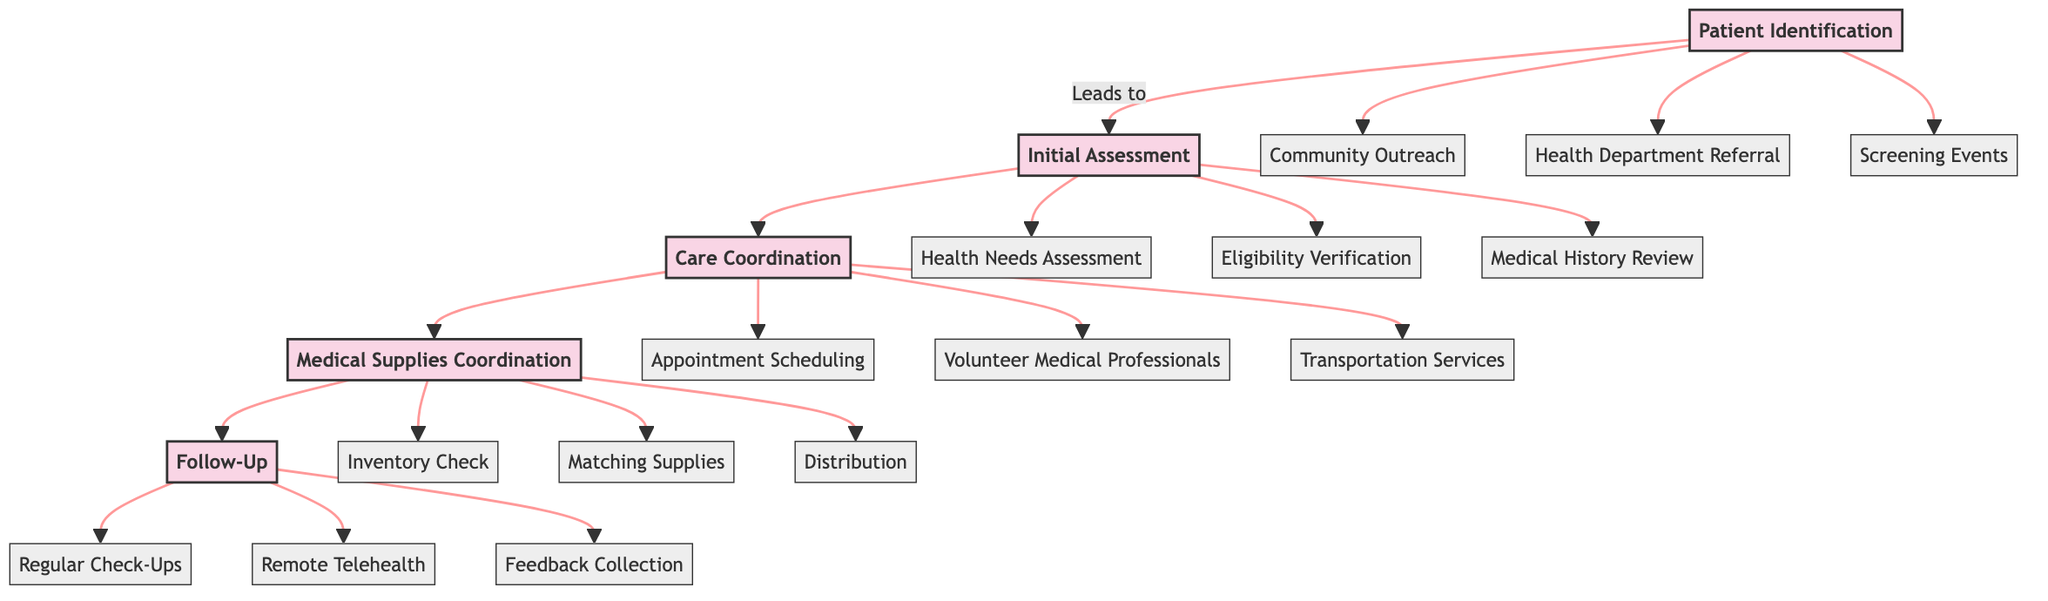How many phases are there in the clinical pathway? The diagram lists five distinct phases: Patient Identification, Initial Assessment, Care Coordination, Medical Supplies Coordination, and Follow-Up. Counting these gives a total of five phases.
Answer: 5 What is the first step in the Patient Identification phase? The first step listed under the Patient Identification phase is "Community Outreach Programs." This is explicitly shown as the first element connected to the Patient Identification node.
Answer: Community Outreach Programs Which phase directly follows the Initial Assessment phase? According to the flow of the diagram, the Care Coordination phase directly follows the Initial Assessment phase, as indicated by the arrow connecting the two phases.
Answer: Care Coordination What are the steps involved in the Medical Supplies Coordination phase? The Medical Supplies Coordination phase includes three steps: Inventory Check, Matching Supplies, and Distribution. These steps are listed under the respective phase in the diagram.
Answer: Inventory Check, Matching Supplies, Distribution How does the Follow-Up phase collect feedback? The Follow-Up phase collects feedback through "Feedback Collection and Continuous Improvement through Local Health Surveys," as indicated in the diagram. This specifies how feedback is obtained.
Answer: Feedback Collection and Continuous Improvement through Local Health Surveys What is the relationship between Care Coordination and Transportation Services? Transportation Services is one of the steps in the Care Coordination phase, showing that it is a key activity within that phase, which is aimed at coordinating care for patients.
Answer: Transportation Services is a step in Care Coordination Which two steps are involved in the Initial Assessment phase? The Initial Assessment phase includes Health Needs Assessment and Eligibility Verification, among others. Specifically, to identify these steps, we can look at the list presented under this phase in the diagram.
Answer: Health Needs Assessment, Eligibility Verification What is the last phase in the clinical pathway? The last phase in the clinical pathway is Follow-Up, as it is represented as the final node in the sequence that connects all the previous phases.
Answer: Follow-Up How many steps are there in the Care Coordination phase? The Care Coordination phase includes three steps: Appointment Scheduling, Volunteer Medical Professionals, and Transportation Services. This can be confirmed by counting the items listed under this phase.
Answer: 3 